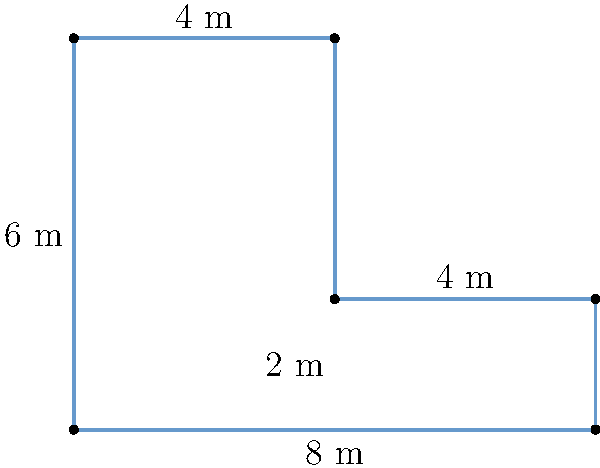As a professional portrait photographer, you're designing a new L-shaped studio. The floor plan is shown above, with measurements in meters. What is the perimeter of this studio space? To find the perimeter, we need to add up all the exterior sides of the L-shaped studio:

1. Left side: $6$ m
2. Top left: $4$ m
3. Right side (top section): $4$ m
4. Right side (bottom section): $2$ m
5. Bottom: $8$ m
6. Interior vertical segment: $4$ m

Adding these together:

$$6 + 4 + 4 + 2 + 8 + 4 = 28$$

Therefore, the perimeter of the L-shaped studio is $28$ meters.
Answer: $28$ m 